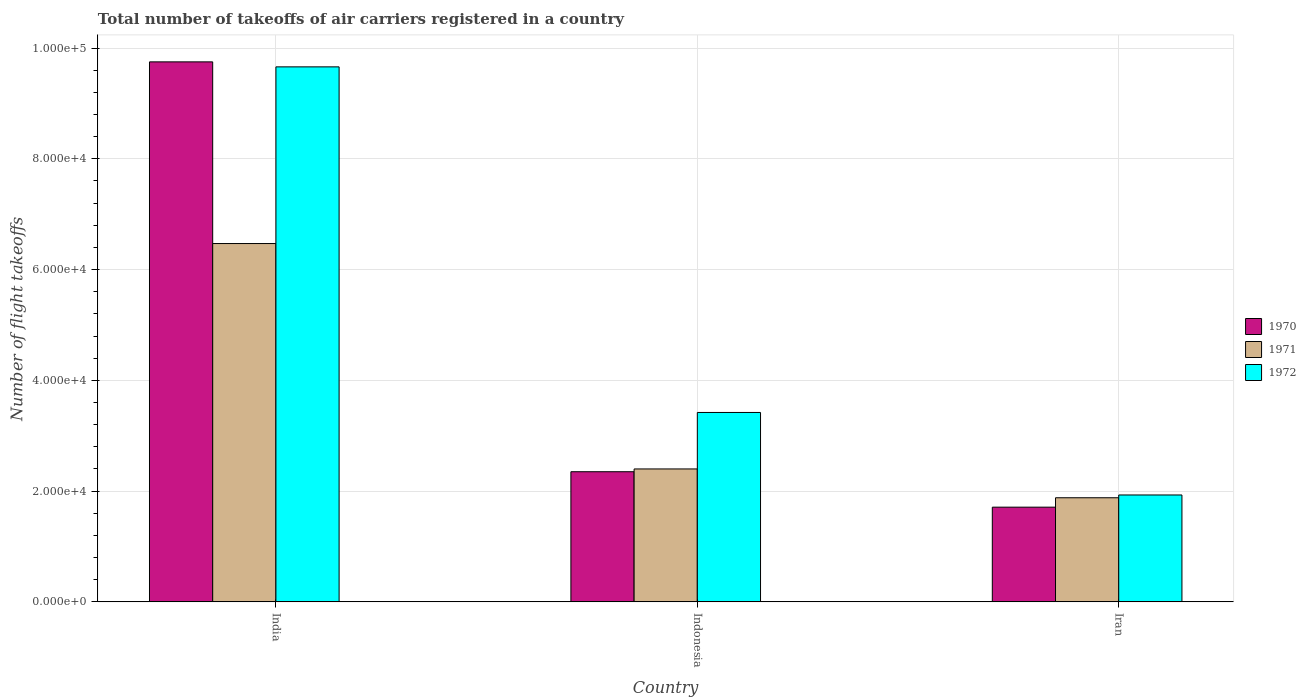How many different coloured bars are there?
Ensure brevity in your answer.  3. How many bars are there on the 1st tick from the left?
Offer a terse response. 3. What is the label of the 2nd group of bars from the left?
Offer a very short reply. Indonesia. In how many cases, is the number of bars for a given country not equal to the number of legend labels?
Provide a short and direct response. 0. What is the total number of flight takeoffs in 1970 in India?
Make the answer very short. 9.75e+04. Across all countries, what is the maximum total number of flight takeoffs in 1972?
Your response must be concise. 9.66e+04. Across all countries, what is the minimum total number of flight takeoffs in 1970?
Provide a succinct answer. 1.71e+04. In which country was the total number of flight takeoffs in 1972 minimum?
Your answer should be very brief. Iran. What is the total total number of flight takeoffs in 1972 in the graph?
Ensure brevity in your answer.  1.50e+05. What is the difference between the total number of flight takeoffs in 1972 in India and that in Iran?
Your answer should be very brief. 7.73e+04. What is the difference between the total number of flight takeoffs in 1972 in Iran and the total number of flight takeoffs in 1971 in India?
Make the answer very short. -4.54e+04. What is the average total number of flight takeoffs in 1971 per country?
Your answer should be very brief. 3.58e+04. What is the difference between the total number of flight takeoffs of/in 1970 and total number of flight takeoffs of/in 1971 in Indonesia?
Provide a short and direct response. -500. In how many countries, is the total number of flight takeoffs in 1971 greater than 76000?
Provide a short and direct response. 0. What is the ratio of the total number of flight takeoffs in 1972 in Indonesia to that in Iran?
Keep it short and to the point. 1.77. Is the total number of flight takeoffs in 1971 in Indonesia less than that in Iran?
Give a very brief answer. No. What is the difference between the highest and the second highest total number of flight takeoffs in 1970?
Give a very brief answer. -6400. What is the difference between the highest and the lowest total number of flight takeoffs in 1971?
Your answer should be compact. 4.59e+04. What does the 1st bar from the right in Iran represents?
Provide a short and direct response. 1972. How many bars are there?
Provide a succinct answer. 9. Are all the bars in the graph horizontal?
Your answer should be very brief. No. How many countries are there in the graph?
Provide a succinct answer. 3. Does the graph contain any zero values?
Keep it short and to the point. No. Does the graph contain grids?
Ensure brevity in your answer.  Yes. How many legend labels are there?
Your answer should be compact. 3. How are the legend labels stacked?
Offer a very short reply. Vertical. What is the title of the graph?
Your response must be concise. Total number of takeoffs of air carriers registered in a country. What is the label or title of the X-axis?
Give a very brief answer. Country. What is the label or title of the Y-axis?
Offer a terse response. Number of flight takeoffs. What is the Number of flight takeoffs in 1970 in India?
Provide a short and direct response. 9.75e+04. What is the Number of flight takeoffs in 1971 in India?
Keep it short and to the point. 6.47e+04. What is the Number of flight takeoffs in 1972 in India?
Your answer should be compact. 9.66e+04. What is the Number of flight takeoffs of 1970 in Indonesia?
Provide a succinct answer. 2.35e+04. What is the Number of flight takeoffs in 1971 in Indonesia?
Give a very brief answer. 2.40e+04. What is the Number of flight takeoffs in 1972 in Indonesia?
Make the answer very short. 3.42e+04. What is the Number of flight takeoffs in 1970 in Iran?
Offer a terse response. 1.71e+04. What is the Number of flight takeoffs in 1971 in Iran?
Provide a succinct answer. 1.88e+04. What is the Number of flight takeoffs in 1972 in Iran?
Your answer should be very brief. 1.93e+04. Across all countries, what is the maximum Number of flight takeoffs in 1970?
Provide a short and direct response. 9.75e+04. Across all countries, what is the maximum Number of flight takeoffs of 1971?
Offer a very short reply. 6.47e+04. Across all countries, what is the maximum Number of flight takeoffs in 1972?
Provide a succinct answer. 9.66e+04. Across all countries, what is the minimum Number of flight takeoffs of 1970?
Give a very brief answer. 1.71e+04. Across all countries, what is the minimum Number of flight takeoffs in 1971?
Provide a succinct answer. 1.88e+04. Across all countries, what is the minimum Number of flight takeoffs of 1972?
Provide a succinct answer. 1.93e+04. What is the total Number of flight takeoffs of 1970 in the graph?
Keep it short and to the point. 1.38e+05. What is the total Number of flight takeoffs in 1971 in the graph?
Your response must be concise. 1.08e+05. What is the total Number of flight takeoffs of 1972 in the graph?
Your answer should be compact. 1.50e+05. What is the difference between the Number of flight takeoffs in 1970 in India and that in Indonesia?
Ensure brevity in your answer.  7.40e+04. What is the difference between the Number of flight takeoffs in 1971 in India and that in Indonesia?
Your answer should be very brief. 4.07e+04. What is the difference between the Number of flight takeoffs of 1972 in India and that in Indonesia?
Offer a very short reply. 6.24e+04. What is the difference between the Number of flight takeoffs in 1970 in India and that in Iran?
Offer a very short reply. 8.04e+04. What is the difference between the Number of flight takeoffs of 1971 in India and that in Iran?
Offer a very short reply. 4.59e+04. What is the difference between the Number of flight takeoffs in 1972 in India and that in Iran?
Your answer should be very brief. 7.73e+04. What is the difference between the Number of flight takeoffs of 1970 in Indonesia and that in Iran?
Provide a succinct answer. 6400. What is the difference between the Number of flight takeoffs in 1971 in Indonesia and that in Iran?
Keep it short and to the point. 5200. What is the difference between the Number of flight takeoffs of 1972 in Indonesia and that in Iran?
Keep it short and to the point. 1.49e+04. What is the difference between the Number of flight takeoffs of 1970 in India and the Number of flight takeoffs of 1971 in Indonesia?
Offer a terse response. 7.35e+04. What is the difference between the Number of flight takeoffs of 1970 in India and the Number of flight takeoffs of 1972 in Indonesia?
Your response must be concise. 6.33e+04. What is the difference between the Number of flight takeoffs in 1971 in India and the Number of flight takeoffs in 1972 in Indonesia?
Provide a short and direct response. 3.05e+04. What is the difference between the Number of flight takeoffs of 1970 in India and the Number of flight takeoffs of 1971 in Iran?
Give a very brief answer. 7.87e+04. What is the difference between the Number of flight takeoffs of 1970 in India and the Number of flight takeoffs of 1972 in Iran?
Give a very brief answer. 7.82e+04. What is the difference between the Number of flight takeoffs in 1971 in India and the Number of flight takeoffs in 1972 in Iran?
Provide a succinct answer. 4.54e+04. What is the difference between the Number of flight takeoffs of 1970 in Indonesia and the Number of flight takeoffs of 1971 in Iran?
Provide a succinct answer. 4700. What is the difference between the Number of flight takeoffs of 1970 in Indonesia and the Number of flight takeoffs of 1972 in Iran?
Keep it short and to the point. 4200. What is the difference between the Number of flight takeoffs of 1971 in Indonesia and the Number of flight takeoffs of 1972 in Iran?
Your answer should be very brief. 4700. What is the average Number of flight takeoffs in 1970 per country?
Give a very brief answer. 4.60e+04. What is the average Number of flight takeoffs in 1971 per country?
Provide a succinct answer. 3.58e+04. What is the average Number of flight takeoffs in 1972 per country?
Give a very brief answer. 5.00e+04. What is the difference between the Number of flight takeoffs of 1970 and Number of flight takeoffs of 1971 in India?
Your answer should be compact. 3.28e+04. What is the difference between the Number of flight takeoffs in 1970 and Number of flight takeoffs in 1972 in India?
Provide a succinct answer. 900. What is the difference between the Number of flight takeoffs in 1971 and Number of flight takeoffs in 1972 in India?
Offer a terse response. -3.19e+04. What is the difference between the Number of flight takeoffs in 1970 and Number of flight takeoffs in 1971 in Indonesia?
Your response must be concise. -500. What is the difference between the Number of flight takeoffs of 1970 and Number of flight takeoffs of 1972 in Indonesia?
Provide a succinct answer. -1.07e+04. What is the difference between the Number of flight takeoffs of 1971 and Number of flight takeoffs of 1972 in Indonesia?
Give a very brief answer. -1.02e+04. What is the difference between the Number of flight takeoffs of 1970 and Number of flight takeoffs of 1971 in Iran?
Your answer should be very brief. -1700. What is the difference between the Number of flight takeoffs in 1970 and Number of flight takeoffs in 1972 in Iran?
Make the answer very short. -2200. What is the difference between the Number of flight takeoffs in 1971 and Number of flight takeoffs in 1972 in Iran?
Provide a succinct answer. -500. What is the ratio of the Number of flight takeoffs of 1970 in India to that in Indonesia?
Give a very brief answer. 4.15. What is the ratio of the Number of flight takeoffs in 1971 in India to that in Indonesia?
Give a very brief answer. 2.7. What is the ratio of the Number of flight takeoffs of 1972 in India to that in Indonesia?
Your answer should be compact. 2.82. What is the ratio of the Number of flight takeoffs in 1970 in India to that in Iran?
Offer a terse response. 5.7. What is the ratio of the Number of flight takeoffs of 1971 in India to that in Iran?
Your answer should be very brief. 3.44. What is the ratio of the Number of flight takeoffs of 1972 in India to that in Iran?
Offer a very short reply. 5.01. What is the ratio of the Number of flight takeoffs in 1970 in Indonesia to that in Iran?
Keep it short and to the point. 1.37. What is the ratio of the Number of flight takeoffs in 1971 in Indonesia to that in Iran?
Provide a short and direct response. 1.28. What is the ratio of the Number of flight takeoffs in 1972 in Indonesia to that in Iran?
Your answer should be very brief. 1.77. What is the difference between the highest and the second highest Number of flight takeoffs in 1970?
Make the answer very short. 7.40e+04. What is the difference between the highest and the second highest Number of flight takeoffs in 1971?
Provide a short and direct response. 4.07e+04. What is the difference between the highest and the second highest Number of flight takeoffs in 1972?
Make the answer very short. 6.24e+04. What is the difference between the highest and the lowest Number of flight takeoffs in 1970?
Give a very brief answer. 8.04e+04. What is the difference between the highest and the lowest Number of flight takeoffs of 1971?
Make the answer very short. 4.59e+04. What is the difference between the highest and the lowest Number of flight takeoffs in 1972?
Offer a terse response. 7.73e+04. 